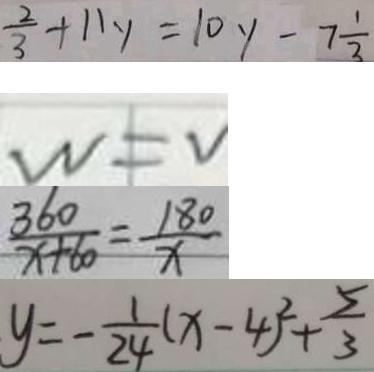Convert formula to latex. <formula><loc_0><loc_0><loc_500><loc_500>\frac { 2 } { 3 } + 1 1 y = 1 0 y - 7 \frac { 1 } { 3 } 
 w = v 
 \frac { 3 6 0 } { x + 6 0 } = \frac { 1 8 0 } { x } 
 y = - \frac { 1 } { 2 4 } ( x - 4 ) ^ { 2 } + \frac { 5 } { 3 }</formula> 